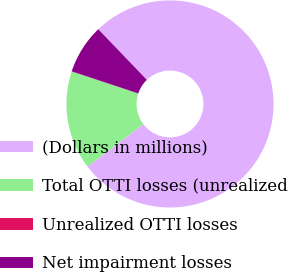<chart> <loc_0><loc_0><loc_500><loc_500><pie_chart><fcel>(Dollars in millions)<fcel>Total OTTI losses (unrealized<fcel>Unrealized OTTI losses<fcel>Net impairment losses<nl><fcel>76.84%<fcel>15.4%<fcel>0.04%<fcel>7.72%<nl></chart> 